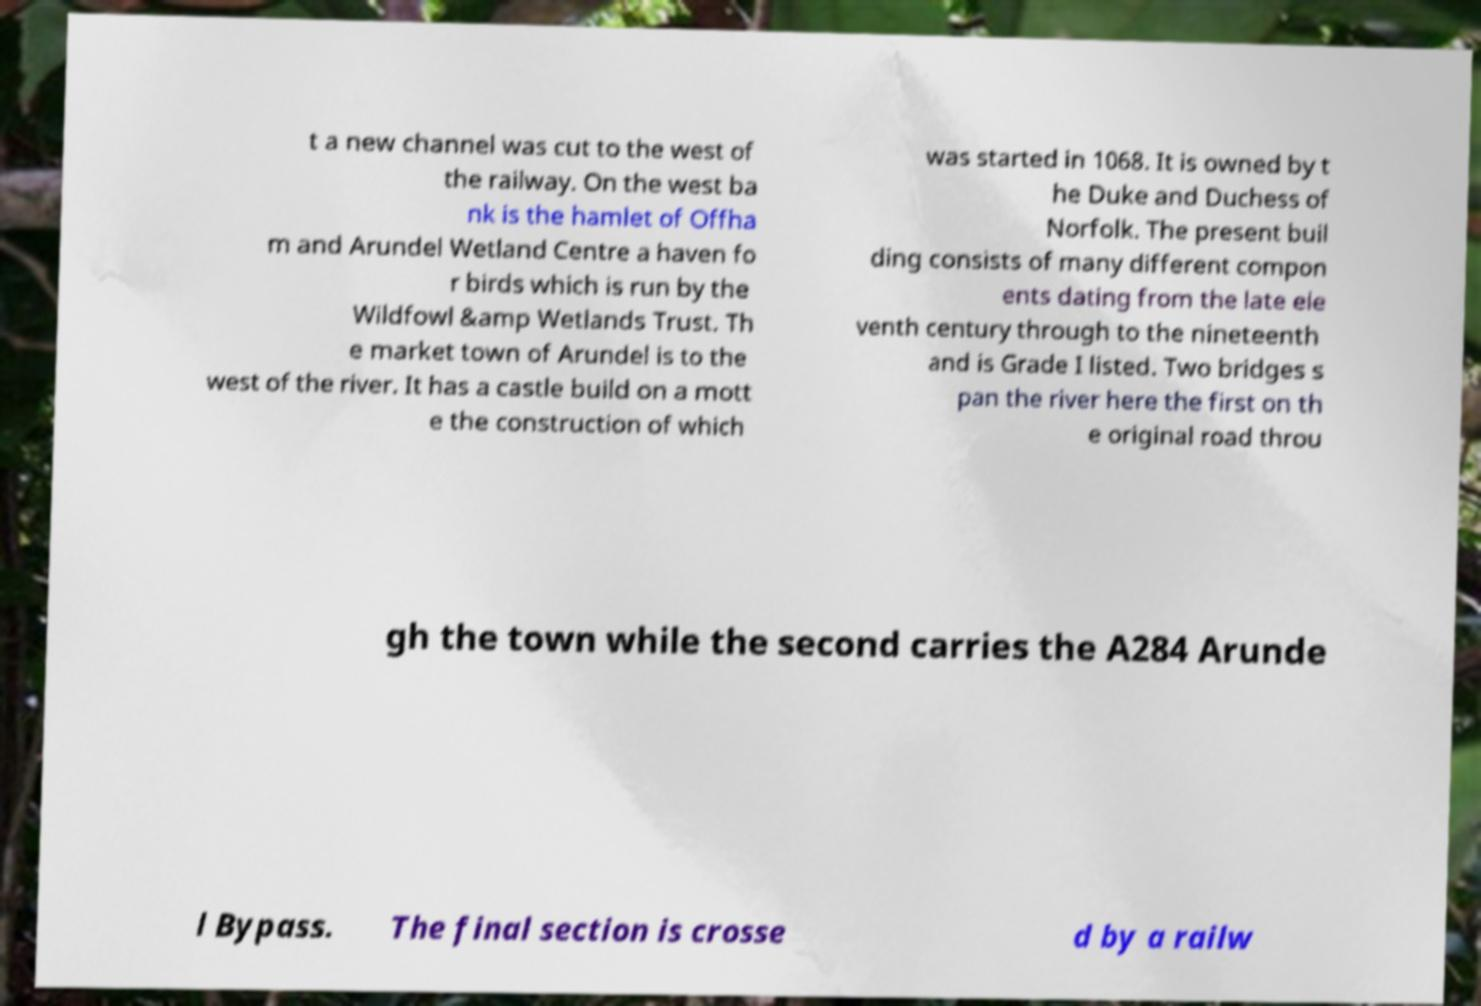Could you assist in decoding the text presented in this image and type it out clearly? t a new channel was cut to the west of the railway. On the west ba nk is the hamlet of Offha m and Arundel Wetland Centre a haven fo r birds which is run by the Wildfowl &amp Wetlands Trust. Th e market town of Arundel is to the west of the river. It has a castle build on a mott e the construction of which was started in 1068. It is owned by t he Duke and Duchess of Norfolk. The present buil ding consists of many different compon ents dating from the late ele venth century through to the nineteenth and is Grade I listed. Two bridges s pan the river here the first on th e original road throu gh the town while the second carries the A284 Arunde l Bypass. The final section is crosse d by a railw 